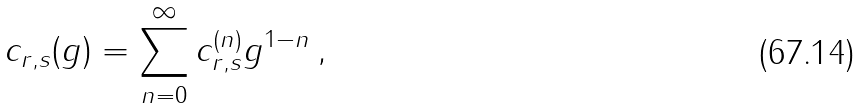Convert formula to latex. <formula><loc_0><loc_0><loc_500><loc_500>c _ { r , s } ( g ) = \sum _ { n = 0 } ^ { \infty } c _ { r , s } ^ { ( n ) } g ^ { 1 - n } \, ,</formula> 